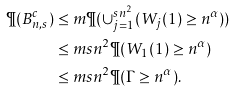Convert formula to latex. <formula><loc_0><loc_0><loc_500><loc_500>\P ( B ^ { c } _ { n , s } ) & \leq m \P ( \cup _ { j = 1 } ^ { s n ^ { 2 } } ( W _ { j } ( 1 ) \geq n ^ { \alpha } ) ) \\ & \leq m s n ^ { 2 } \P ( W _ { 1 } ( 1 ) \geq n ^ { \alpha } ) \\ & \leq m s n ^ { 2 } \P ( \Gamma \geq n ^ { \alpha } ) .</formula> 